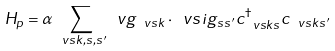<formula> <loc_0><loc_0><loc_500><loc_500>H _ { p } = \alpha \sum _ { \ v s k , s , s ^ { \prime } } \ v g _ { \ v s k } \cdot \ v s i g _ { s s ^ { \prime } } c ^ { \dag } _ { \ v s k s } c _ { \ v s k s ^ { \prime } }</formula> 